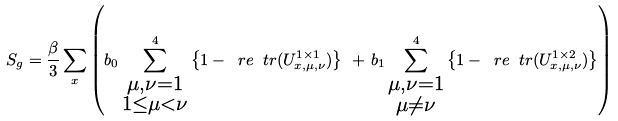<formula> <loc_0><loc_0><loc_500><loc_500>S _ { g } = \frac { \beta } { 3 } \sum _ { x } \left ( b _ { 0 } \sum _ { \substack { \mu , \nu = 1 \\ 1 \leq \mu < \nu } } ^ { 4 } \left \{ 1 - \ r e \ t r ( U ^ { 1 \times 1 } _ { x , \mu , \nu } ) \right \} \Big . \Big . \, + \, b _ { 1 } \sum _ { \substack { \mu , \nu = 1 \\ \mu \neq \nu } } ^ { 4 } \left \{ 1 - \ r e \ t r ( U ^ { 1 \times 2 } _ { x , \mu , \nu } ) \right \} \right ) \,</formula> 